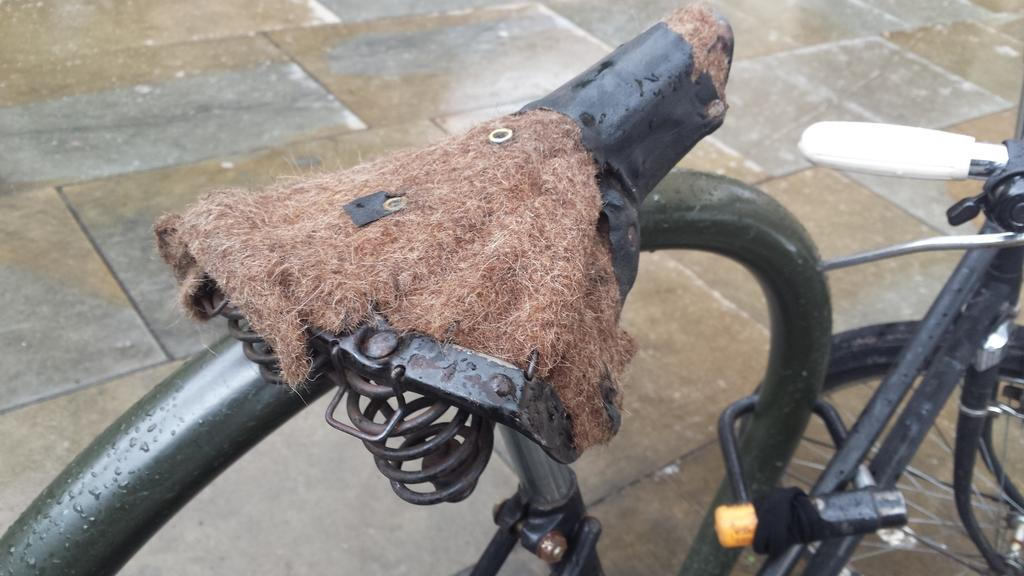What is the main object in the image? There is a bicycle in the image. What material is used for the bicycle seat? The bicycle seat is made up of coir. What type of surface can be seen in the background of the image? There is a floor visible in the background of the image. Where is the nearest hospital to the location of the bicycle in the image? The provided facts do not give any information about the location of the bicycle or the presence of a hospital, so it cannot be determined from the image. 